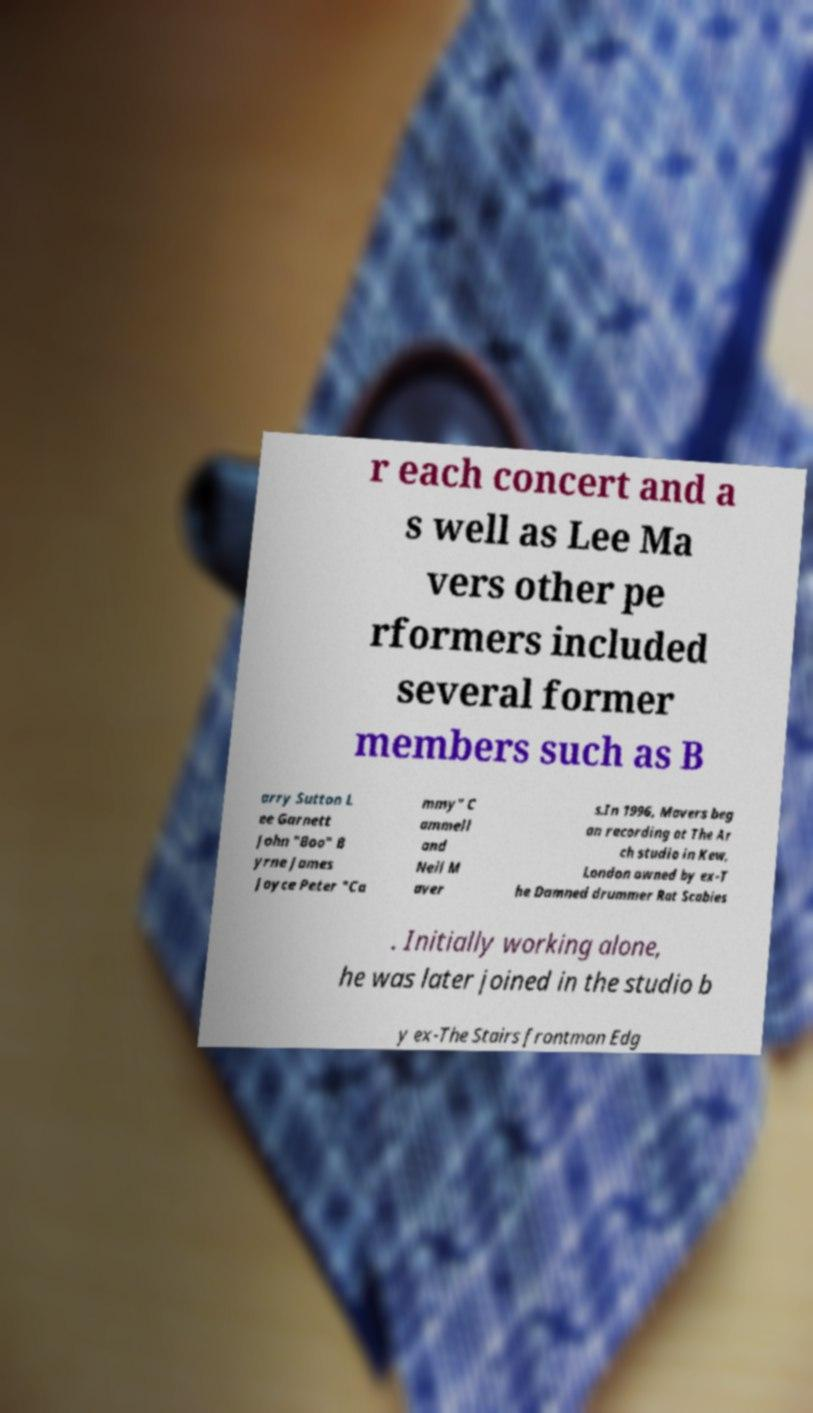Could you extract and type out the text from this image? r each concert and a s well as Lee Ma vers other pe rformers included several former members such as B arry Sutton L ee Garnett John "Boo" B yrne James Joyce Peter "Ca mmy" C ammell and Neil M aver s.In 1996, Mavers beg an recording at The Ar ch studio in Kew, London owned by ex-T he Damned drummer Rat Scabies . Initially working alone, he was later joined in the studio b y ex-The Stairs frontman Edg 